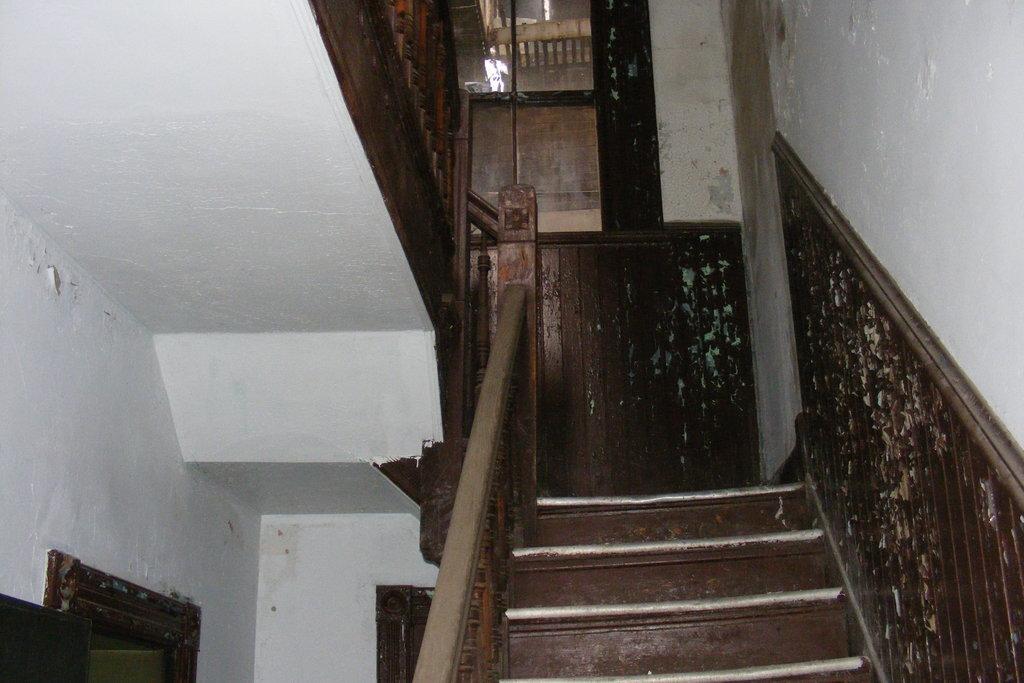In one or two sentences, can you explain what this image depicts? In this image, we can see the stairs and railing. We can also see the wall. 